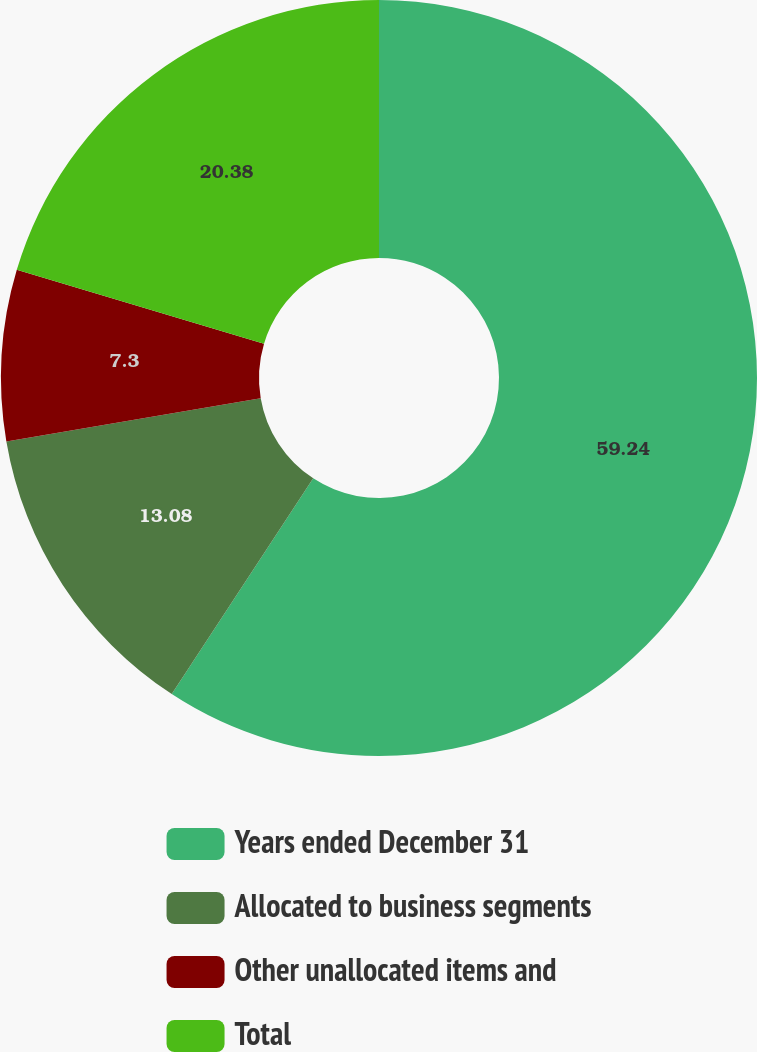<chart> <loc_0><loc_0><loc_500><loc_500><pie_chart><fcel>Years ended December 31<fcel>Allocated to business segments<fcel>Other unallocated items and<fcel>Total<nl><fcel>59.23%<fcel>13.08%<fcel>7.3%<fcel>20.38%<nl></chart> 